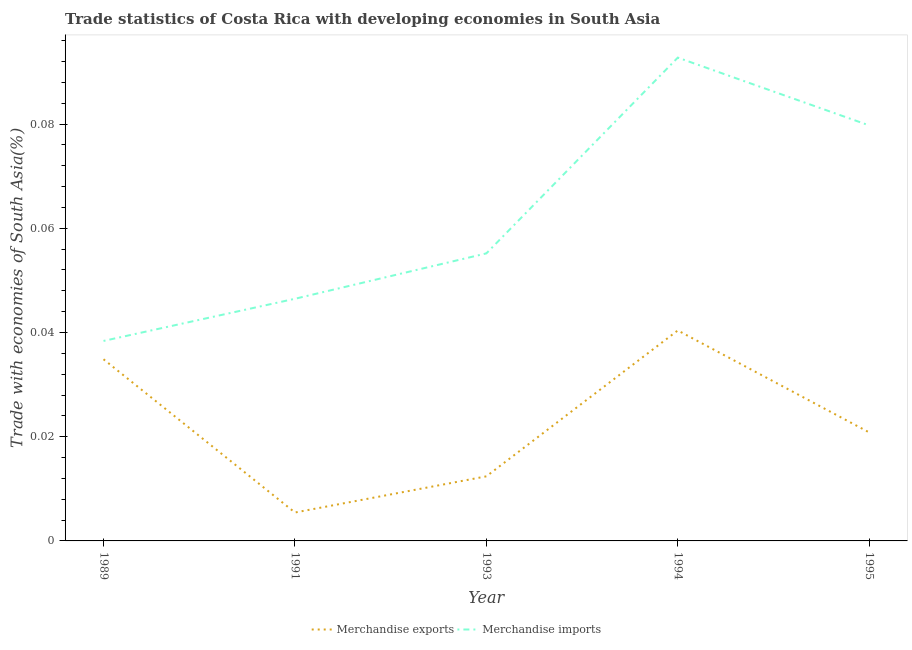How many different coloured lines are there?
Provide a short and direct response. 2. Is the number of lines equal to the number of legend labels?
Keep it short and to the point. Yes. What is the merchandise imports in 1993?
Offer a very short reply. 0.06. Across all years, what is the maximum merchandise imports?
Keep it short and to the point. 0.09. Across all years, what is the minimum merchandise exports?
Keep it short and to the point. 0.01. What is the total merchandise exports in the graph?
Provide a succinct answer. 0.11. What is the difference between the merchandise imports in 1991 and that in 1994?
Provide a succinct answer. -0.05. What is the difference between the merchandise imports in 1991 and the merchandise exports in 1995?
Your answer should be very brief. 0.03. What is the average merchandise imports per year?
Your answer should be compact. 0.06. In the year 1991, what is the difference between the merchandise imports and merchandise exports?
Your response must be concise. 0.04. In how many years, is the merchandise exports greater than 0.004 %?
Offer a very short reply. 5. What is the ratio of the merchandise imports in 1993 to that in 1994?
Ensure brevity in your answer.  0.59. Is the merchandise imports in 1989 less than that in 1993?
Make the answer very short. Yes. Is the difference between the merchandise exports in 1989 and 1993 greater than the difference between the merchandise imports in 1989 and 1993?
Offer a very short reply. Yes. What is the difference between the highest and the second highest merchandise imports?
Offer a terse response. 0.01. What is the difference between the highest and the lowest merchandise exports?
Keep it short and to the point. 0.03. In how many years, is the merchandise exports greater than the average merchandise exports taken over all years?
Provide a short and direct response. 2. Is the sum of the merchandise imports in 1994 and 1995 greater than the maximum merchandise exports across all years?
Your response must be concise. Yes. Does the merchandise imports monotonically increase over the years?
Offer a terse response. No. Is the merchandise imports strictly greater than the merchandise exports over the years?
Make the answer very short. Yes. Is the merchandise imports strictly less than the merchandise exports over the years?
Make the answer very short. No. How many years are there in the graph?
Offer a terse response. 5. What is the difference between two consecutive major ticks on the Y-axis?
Provide a short and direct response. 0.02. Are the values on the major ticks of Y-axis written in scientific E-notation?
Offer a very short reply. No. Does the graph contain any zero values?
Keep it short and to the point. No. Does the graph contain grids?
Your answer should be very brief. No. What is the title of the graph?
Your answer should be very brief. Trade statistics of Costa Rica with developing economies in South Asia. What is the label or title of the X-axis?
Offer a very short reply. Year. What is the label or title of the Y-axis?
Keep it short and to the point. Trade with economies of South Asia(%). What is the Trade with economies of South Asia(%) in Merchandise exports in 1989?
Your response must be concise. 0.03. What is the Trade with economies of South Asia(%) of Merchandise imports in 1989?
Your answer should be very brief. 0.04. What is the Trade with economies of South Asia(%) of Merchandise exports in 1991?
Your answer should be very brief. 0.01. What is the Trade with economies of South Asia(%) in Merchandise imports in 1991?
Provide a short and direct response. 0.05. What is the Trade with economies of South Asia(%) of Merchandise exports in 1993?
Offer a very short reply. 0.01. What is the Trade with economies of South Asia(%) of Merchandise imports in 1993?
Make the answer very short. 0.06. What is the Trade with economies of South Asia(%) in Merchandise exports in 1994?
Your answer should be very brief. 0.04. What is the Trade with economies of South Asia(%) of Merchandise imports in 1994?
Provide a short and direct response. 0.09. What is the Trade with economies of South Asia(%) in Merchandise exports in 1995?
Keep it short and to the point. 0.02. What is the Trade with economies of South Asia(%) of Merchandise imports in 1995?
Your answer should be compact. 0.08. Across all years, what is the maximum Trade with economies of South Asia(%) of Merchandise exports?
Your response must be concise. 0.04. Across all years, what is the maximum Trade with economies of South Asia(%) of Merchandise imports?
Your answer should be compact. 0.09. Across all years, what is the minimum Trade with economies of South Asia(%) in Merchandise exports?
Provide a succinct answer. 0.01. Across all years, what is the minimum Trade with economies of South Asia(%) of Merchandise imports?
Keep it short and to the point. 0.04. What is the total Trade with economies of South Asia(%) of Merchandise exports in the graph?
Make the answer very short. 0.11. What is the total Trade with economies of South Asia(%) in Merchandise imports in the graph?
Ensure brevity in your answer.  0.31. What is the difference between the Trade with economies of South Asia(%) of Merchandise exports in 1989 and that in 1991?
Your response must be concise. 0.03. What is the difference between the Trade with economies of South Asia(%) in Merchandise imports in 1989 and that in 1991?
Your answer should be compact. -0.01. What is the difference between the Trade with economies of South Asia(%) in Merchandise exports in 1989 and that in 1993?
Your answer should be very brief. 0.02. What is the difference between the Trade with economies of South Asia(%) of Merchandise imports in 1989 and that in 1993?
Provide a succinct answer. -0.02. What is the difference between the Trade with economies of South Asia(%) in Merchandise exports in 1989 and that in 1994?
Your answer should be very brief. -0.01. What is the difference between the Trade with economies of South Asia(%) in Merchandise imports in 1989 and that in 1994?
Provide a short and direct response. -0.05. What is the difference between the Trade with economies of South Asia(%) in Merchandise exports in 1989 and that in 1995?
Ensure brevity in your answer.  0.01. What is the difference between the Trade with economies of South Asia(%) in Merchandise imports in 1989 and that in 1995?
Keep it short and to the point. -0.04. What is the difference between the Trade with economies of South Asia(%) of Merchandise exports in 1991 and that in 1993?
Ensure brevity in your answer.  -0.01. What is the difference between the Trade with economies of South Asia(%) in Merchandise imports in 1991 and that in 1993?
Provide a succinct answer. -0.01. What is the difference between the Trade with economies of South Asia(%) in Merchandise exports in 1991 and that in 1994?
Ensure brevity in your answer.  -0.03. What is the difference between the Trade with economies of South Asia(%) in Merchandise imports in 1991 and that in 1994?
Your response must be concise. -0.05. What is the difference between the Trade with economies of South Asia(%) in Merchandise exports in 1991 and that in 1995?
Keep it short and to the point. -0.02. What is the difference between the Trade with economies of South Asia(%) in Merchandise imports in 1991 and that in 1995?
Provide a succinct answer. -0.03. What is the difference between the Trade with economies of South Asia(%) of Merchandise exports in 1993 and that in 1994?
Offer a terse response. -0.03. What is the difference between the Trade with economies of South Asia(%) in Merchandise imports in 1993 and that in 1994?
Your answer should be very brief. -0.04. What is the difference between the Trade with economies of South Asia(%) of Merchandise exports in 1993 and that in 1995?
Provide a short and direct response. -0.01. What is the difference between the Trade with economies of South Asia(%) in Merchandise imports in 1993 and that in 1995?
Your response must be concise. -0.02. What is the difference between the Trade with economies of South Asia(%) of Merchandise exports in 1994 and that in 1995?
Provide a succinct answer. 0.02. What is the difference between the Trade with economies of South Asia(%) in Merchandise imports in 1994 and that in 1995?
Give a very brief answer. 0.01. What is the difference between the Trade with economies of South Asia(%) of Merchandise exports in 1989 and the Trade with economies of South Asia(%) of Merchandise imports in 1991?
Ensure brevity in your answer.  -0.01. What is the difference between the Trade with economies of South Asia(%) of Merchandise exports in 1989 and the Trade with economies of South Asia(%) of Merchandise imports in 1993?
Provide a succinct answer. -0.02. What is the difference between the Trade with economies of South Asia(%) of Merchandise exports in 1989 and the Trade with economies of South Asia(%) of Merchandise imports in 1994?
Make the answer very short. -0.06. What is the difference between the Trade with economies of South Asia(%) of Merchandise exports in 1989 and the Trade with economies of South Asia(%) of Merchandise imports in 1995?
Ensure brevity in your answer.  -0.04. What is the difference between the Trade with economies of South Asia(%) in Merchandise exports in 1991 and the Trade with economies of South Asia(%) in Merchandise imports in 1993?
Give a very brief answer. -0.05. What is the difference between the Trade with economies of South Asia(%) of Merchandise exports in 1991 and the Trade with economies of South Asia(%) of Merchandise imports in 1994?
Provide a short and direct response. -0.09. What is the difference between the Trade with economies of South Asia(%) in Merchandise exports in 1991 and the Trade with economies of South Asia(%) in Merchandise imports in 1995?
Your answer should be compact. -0.07. What is the difference between the Trade with economies of South Asia(%) of Merchandise exports in 1993 and the Trade with economies of South Asia(%) of Merchandise imports in 1994?
Give a very brief answer. -0.08. What is the difference between the Trade with economies of South Asia(%) in Merchandise exports in 1993 and the Trade with economies of South Asia(%) in Merchandise imports in 1995?
Your response must be concise. -0.07. What is the difference between the Trade with economies of South Asia(%) in Merchandise exports in 1994 and the Trade with economies of South Asia(%) in Merchandise imports in 1995?
Give a very brief answer. -0.04. What is the average Trade with economies of South Asia(%) in Merchandise exports per year?
Keep it short and to the point. 0.02. What is the average Trade with economies of South Asia(%) in Merchandise imports per year?
Make the answer very short. 0.06. In the year 1989, what is the difference between the Trade with economies of South Asia(%) of Merchandise exports and Trade with economies of South Asia(%) of Merchandise imports?
Ensure brevity in your answer.  -0. In the year 1991, what is the difference between the Trade with economies of South Asia(%) in Merchandise exports and Trade with economies of South Asia(%) in Merchandise imports?
Your answer should be very brief. -0.04. In the year 1993, what is the difference between the Trade with economies of South Asia(%) in Merchandise exports and Trade with economies of South Asia(%) in Merchandise imports?
Ensure brevity in your answer.  -0.04. In the year 1994, what is the difference between the Trade with economies of South Asia(%) in Merchandise exports and Trade with economies of South Asia(%) in Merchandise imports?
Offer a terse response. -0.05. In the year 1995, what is the difference between the Trade with economies of South Asia(%) of Merchandise exports and Trade with economies of South Asia(%) of Merchandise imports?
Keep it short and to the point. -0.06. What is the ratio of the Trade with economies of South Asia(%) of Merchandise exports in 1989 to that in 1991?
Make the answer very short. 6.39. What is the ratio of the Trade with economies of South Asia(%) of Merchandise imports in 1989 to that in 1991?
Offer a very short reply. 0.83. What is the ratio of the Trade with economies of South Asia(%) of Merchandise exports in 1989 to that in 1993?
Your response must be concise. 2.81. What is the ratio of the Trade with economies of South Asia(%) of Merchandise imports in 1989 to that in 1993?
Give a very brief answer. 0.7. What is the ratio of the Trade with economies of South Asia(%) in Merchandise exports in 1989 to that in 1994?
Provide a succinct answer. 0.86. What is the ratio of the Trade with economies of South Asia(%) in Merchandise imports in 1989 to that in 1994?
Ensure brevity in your answer.  0.41. What is the ratio of the Trade with economies of South Asia(%) of Merchandise exports in 1989 to that in 1995?
Your answer should be compact. 1.67. What is the ratio of the Trade with economies of South Asia(%) of Merchandise imports in 1989 to that in 1995?
Provide a succinct answer. 0.48. What is the ratio of the Trade with economies of South Asia(%) of Merchandise exports in 1991 to that in 1993?
Offer a very short reply. 0.44. What is the ratio of the Trade with economies of South Asia(%) of Merchandise imports in 1991 to that in 1993?
Your answer should be compact. 0.84. What is the ratio of the Trade with economies of South Asia(%) of Merchandise exports in 1991 to that in 1994?
Your response must be concise. 0.14. What is the ratio of the Trade with economies of South Asia(%) of Merchandise imports in 1991 to that in 1994?
Provide a short and direct response. 0.5. What is the ratio of the Trade with economies of South Asia(%) of Merchandise exports in 1991 to that in 1995?
Your response must be concise. 0.26. What is the ratio of the Trade with economies of South Asia(%) in Merchandise imports in 1991 to that in 1995?
Offer a very short reply. 0.58. What is the ratio of the Trade with economies of South Asia(%) in Merchandise exports in 1993 to that in 1994?
Provide a succinct answer. 0.31. What is the ratio of the Trade with economies of South Asia(%) of Merchandise imports in 1993 to that in 1994?
Offer a very short reply. 0.59. What is the ratio of the Trade with economies of South Asia(%) in Merchandise exports in 1993 to that in 1995?
Keep it short and to the point. 0.6. What is the ratio of the Trade with economies of South Asia(%) of Merchandise imports in 1993 to that in 1995?
Your response must be concise. 0.69. What is the ratio of the Trade with economies of South Asia(%) in Merchandise exports in 1994 to that in 1995?
Ensure brevity in your answer.  1.94. What is the ratio of the Trade with economies of South Asia(%) of Merchandise imports in 1994 to that in 1995?
Make the answer very short. 1.16. What is the difference between the highest and the second highest Trade with economies of South Asia(%) of Merchandise exports?
Offer a very short reply. 0.01. What is the difference between the highest and the second highest Trade with economies of South Asia(%) in Merchandise imports?
Your answer should be very brief. 0.01. What is the difference between the highest and the lowest Trade with economies of South Asia(%) in Merchandise exports?
Your answer should be very brief. 0.03. What is the difference between the highest and the lowest Trade with economies of South Asia(%) of Merchandise imports?
Make the answer very short. 0.05. 